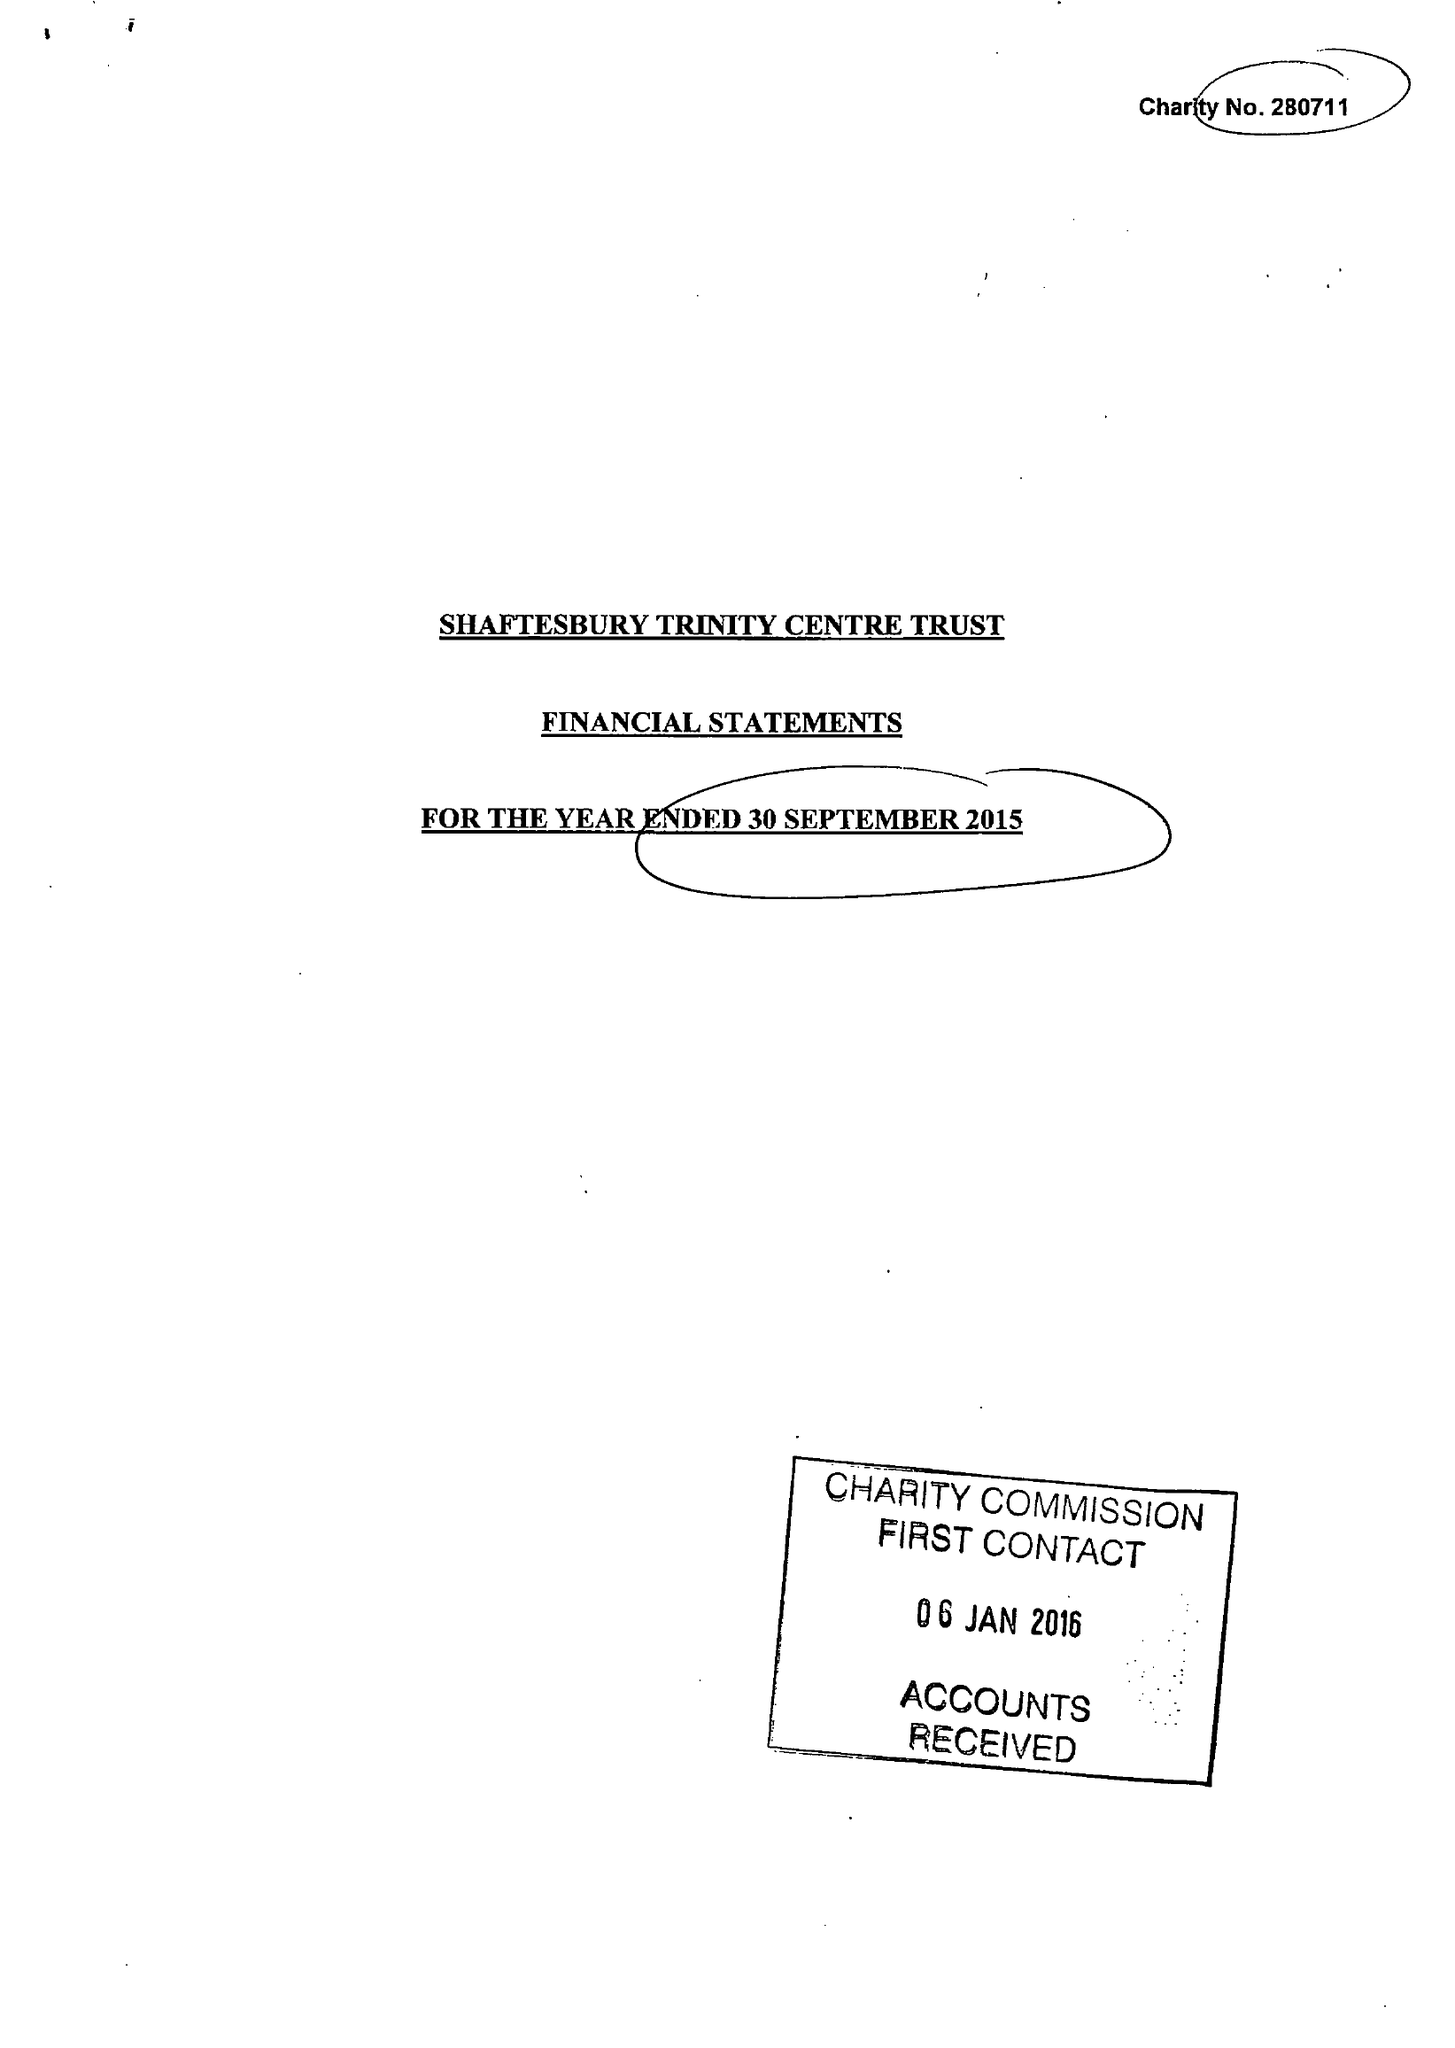What is the value for the address__post_town?
Answer the question using a single word or phrase. GILLINGHAM 